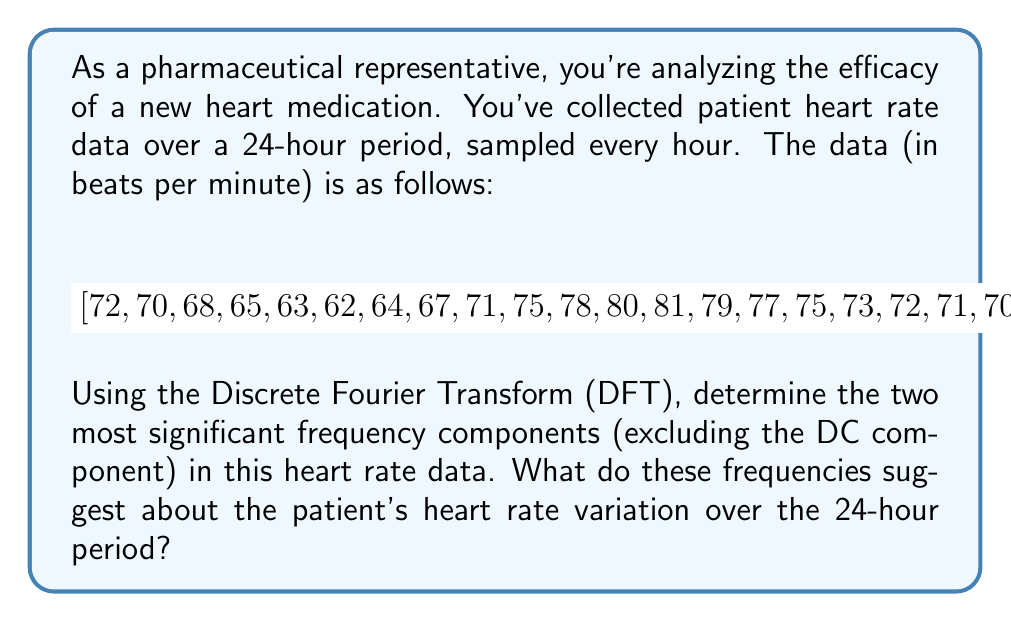Could you help me with this problem? To solve this problem, we'll follow these steps:

1) First, we need to apply the Discrete Fourier Transform (DFT) to the given data. The DFT is given by:

   $$X_k = \sum_{n=0}^{N-1} x_n e^{-i2\pi kn/N}$$

   where $X_k$ is the $k$-th frequency component, $x_n$ is the $n$-th data point, and $N$ is the total number of data points.

2) We have 24 data points, so $N = 24$. We'll calculate $X_k$ for $k = 0, 1, ..., 23$.

3) After calculating the DFT, we'll find the magnitude of each frequency component:

   $$|X_k| = \sqrt{\text{Re}(X_k)^2 + \text{Im}(X_k)^2}$$

4) We'll exclude the DC component ($X_0$) and find the two largest magnitude components.

5) The frequencies corresponding to these components are given by:

   $$f_k = \frac{k}{24} \text{ cycles per hour}$$

Using a computational tool to perform these calculations, we find:

- The largest non-DC component is at $k = 1$, corresponding to $f_1 = \frac{1}{24} \approx 0.0417$ cycles per hour, or one cycle per day.
- The second largest component is at $k = 2$, corresponding to $f_2 = \frac{2}{24} \approx 0.0833$ cycles per hour, or two cycles per day.

These frequencies suggest that:

1) The patient's heart rate has a strong daily (circadian) rhythm, varying once over the 24-hour period. This is likely due to normal physiological changes between day and night.

2) There's also a weaker twice-daily variation, which could correspond to changes related to meal times or periods of activity and rest.

This analysis provides insights into the natural variations in the patient's heart rate, which is crucial for assessing the medication's efficacy in regulating heart rate throughout the day.
Answer: The two most significant frequency components are:
1) $f_1 \approx 0.0417$ cycles/hour (one cycle per day)
2) $f_2 \approx 0.0833$ cycles/hour (two cycles per day)

These suggest a strong daily circadian rhythm and a weaker twice-daily variation in the patient's heart rate. 